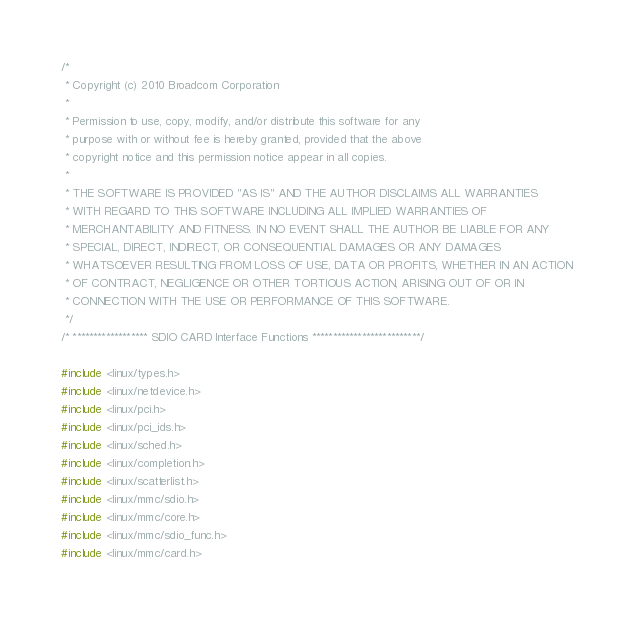Convert code to text. <code><loc_0><loc_0><loc_500><loc_500><_C_>/*
 * Copyright (c) 2010 Broadcom Corporation
 *
 * Permission to use, copy, modify, and/or distribute this software for any
 * purpose with or without fee is hereby granted, provided that the above
 * copyright notice and this permission notice appear in all copies.
 *
 * THE SOFTWARE IS PROVIDED "AS IS" AND THE AUTHOR DISCLAIMS ALL WARRANTIES
 * WITH REGARD TO THIS SOFTWARE INCLUDING ALL IMPLIED WARRANTIES OF
 * MERCHANTABILITY AND FITNESS. IN NO EVENT SHALL THE AUTHOR BE LIABLE FOR ANY
 * SPECIAL, DIRECT, INDIRECT, OR CONSEQUENTIAL DAMAGES OR ANY DAMAGES
 * WHATSOEVER RESULTING FROM LOSS OF USE, DATA OR PROFITS, WHETHER IN AN ACTION
 * OF CONTRACT, NEGLIGENCE OR OTHER TORTIOUS ACTION, ARISING OUT OF OR IN
 * CONNECTION WITH THE USE OR PERFORMANCE OF THIS SOFTWARE.
 */
/* ****************** SDIO CARD Interface Functions **************************/

#include <linux/types.h>
#include <linux/netdevice.h>
#include <linux/pci.h>
#include <linux/pci_ids.h>
#include <linux/sched.h>
#include <linux/completion.h>
#include <linux/scatterlist.h>
#include <linux/mmc/sdio.h>
#include <linux/mmc/core.h>
#include <linux/mmc/sdio_func.h>
#include <linux/mmc/card.h></code> 